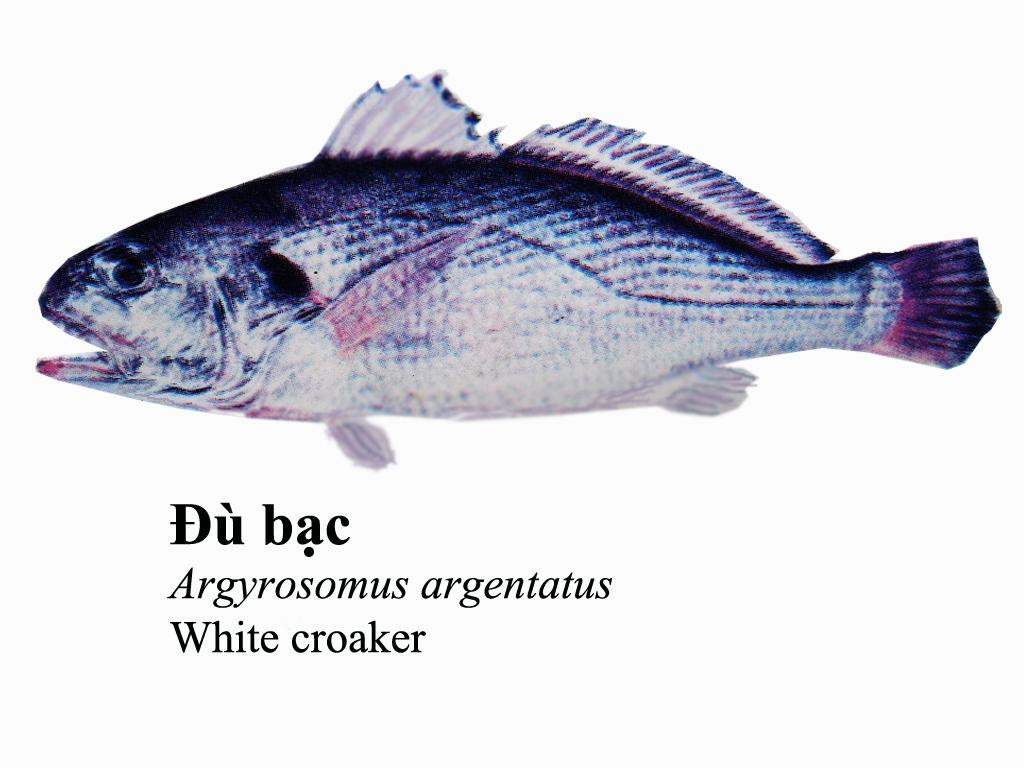What type of animal is in the image? There is a fish in the image. What else can be seen on the image besides the fish? There is text on the image. What type of bean is mentioned in the story on the image? There is no story or bean present in the image; it only features a fish and text. 